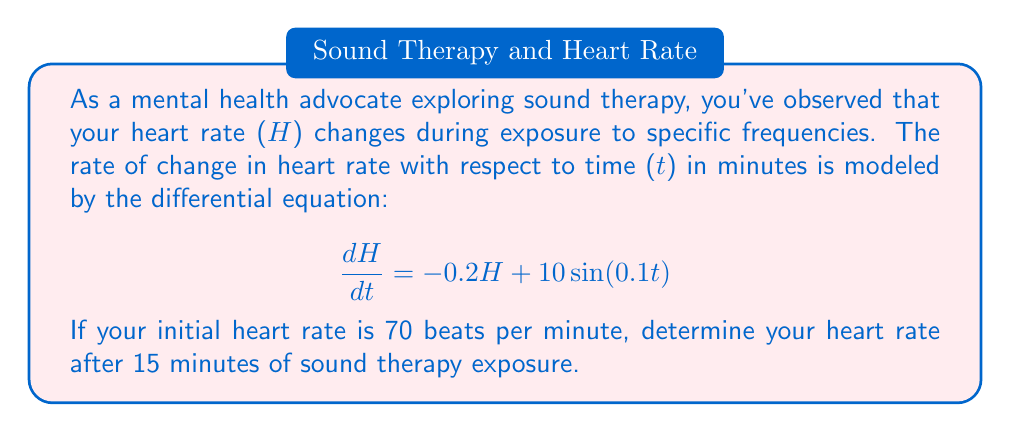Provide a solution to this math problem. To solve this first-order linear differential equation:

1) The general form is: $\frac{dH}{dt} + 0.2H = 10\sin(0.1t)$

2) Find the integrating factor: $\mu(t) = e^{\int 0.2 dt} = e^{0.2t}$

3) Multiply both sides by $\mu(t)$:
   $e^{0.2t}\frac{dH}{dt} + 0.2He^{0.2t} = 10e^{0.2t}\sin(0.1t)$

4) Simplify the left side:
   $\frac{d}{dt}(He^{0.2t}) = 10e^{0.2t}\sin(0.1t)$

5) Integrate both sides:
   $He^{0.2t} = 10\int e^{0.2t}\sin(0.1t)dt$

6) Solve the integral using integration by parts:
   $He^{0.2t} = 10(\frac{e^{0.2t}}{0.04+0.01}(2\sin(0.1t) - \cos(0.1t))) + C$

7) Solve for H:
   $H = \frac{100}{5}(2\sin(0.1t) - \cos(0.1t)) + Ce^{-0.2t}$

8) Use the initial condition H(0) = 70 to find C:
   $70 = -20 + C$
   $C = 90$

9) The particular solution is:
   $H = 20(2\sin(0.1t) - \cos(0.1t)) + 90e^{-0.2t}$

10) Evaluate at t = 15:
    $H(15) = 20(2\sin(1.5) - \cos(1.5)) + 90e^{-3}$
    $H(15) \approx 66.8$ beats per minute
Answer: $66.8$ beats per minute 